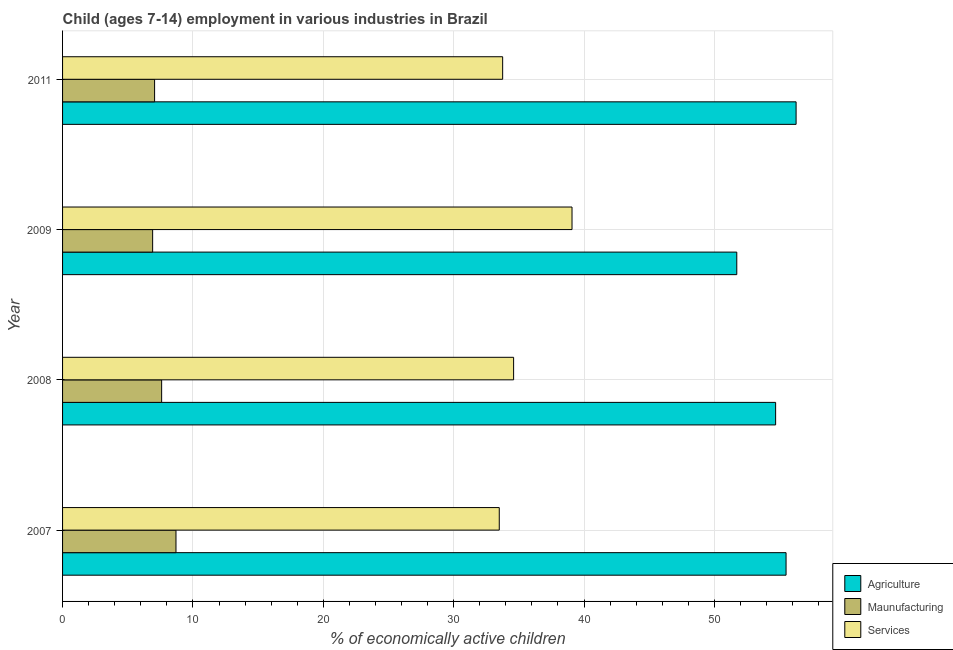How many different coloured bars are there?
Your response must be concise. 3. Are the number of bars per tick equal to the number of legend labels?
Offer a terse response. Yes. Are the number of bars on each tick of the Y-axis equal?
Make the answer very short. Yes. How many bars are there on the 1st tick from the top?
Make the answer very short. 3. How many bars are there on the 2nd tick from the bottom?
Offer a terse response. 3. What is the label of the 1st group of bars from the top?
Your answer should be compact. 2011. In how many cases, is the number of bars for a given year not equal to the number of legend labels?
Give a very brief answer. 0. What is the percentage of economically active children in services in 2011?
Offer a terse response. 33.76. Across all years, what is the maximum percentage of economically active children in agriculture?
Provide a short and direct response. 56.27. Across all years, what is the minimum percentage of economically active children in services?
Your answer should be very brief. 33.5. In which year was the percentage of economically active children in agriculture minimum?
Ensure brevity in your answer.  2009. What is the total percentage of economically active children in manufacturing in the graph?
Your answer should be compact. 30.27. What is the difference between the percentage of economically active children in services in 2007 and that in 2008?
Your answer should be compact. -1.1. What is the difference between the percentage of economically active children in agriculture in 2007 and the percentage of economically active children in manufacturing in 2009?
Your answer should be compact. 48.59. What is the average percentage of economically active children in agriculture per year?
Offer a very short reply. 54.55. In the year 2007, what is the difference between the percentage of economically active children in manufacturing and percentage of economically active children in services?
Provide a short and direct response. -24.8. What is the ratio of the percentage of economically active children in manufacturing in 2007 to that in 2011?
Ensure brevity in your answer.  1.23. What is the difference between the highest and the second highest percentage of economically active children in services?
Your response must be concise. 4.48. What is the difference between the highest and the lowest percentage of economically active children in agriculture?
Keep it short and to the point. 4.55. Is the sum of the percentage of economically active children in manufacturing in 2008 and 2011 greater than the maximum percentage of economically active children in agriculture across all years?
Your response must be concise. No. What does the 1st bar from the top in 2011 represents?
Keep it short and to the point. Services. What does the 3rd bar from the bottom in 2008 represents?
Provide a short and direct response. Services. Is it the case that in every year, the sum of the percentage of economically active children in agriculture and percentage of economically active children in manufacturing is greater than the percentage of economically active children in services?
Make the answer very short. Yes. How many bars are there?
Offer a very short reply. 12. Are all the bars in the graph horizontal?
Give a very brief answer. Yes. How many years are there in the graph?
Offer a very short reply. 4. Are the values on the major ticks of X-axis written in scientific E-notation?
Ensure brevity in your answer.  No. Does the graph contain any zero values?
Your response must be concise. No. How many legend labels are there?
Provide a short and direct response. 3. What is the title of the graph?
Offer a very short reply. Child (ages 7-14) employment in various industries in Brazil. Does "New Zealand" appear as one of the legend labels in the graph?
Give a very brief answer. No. What is the label or title of the X-axis?
Offer a very short reply. % of economically active children. What is the label or title of the Y-axis?
Offer a very short reply. Year. What is the % of economically active children of Agriculture in 2007?
Make the answer very short. 55.5. What is the % of economically active children in Maunufacturing in 2007?
Ensure brevity in your answer.  8.7. What is the % of economically active children of Services in 2007?
Make the answer very short. 33.5. What is the % of economically active children in Agriculture in 2008?
Ensure brevity in your answer.  54.7. What is the % of economically active children of Services in 2008?
Your response must be concise. 34.6. What is the % of economically active children of Agriculture in 2009?
Provide a succinct answer. 51.72. What is the % of economically active children in Maunufacturing in 2009?
Ensure brevity in your answer.  6.91. What is the % of economically active children in Services in 2009?
Give a very brief answer. 39.08. What is the % of economically active children of Agriculture in 2011?
Ensure brevity in your answer.  56.27. What is the % of economically active children in Maunufacturing in 2011?
Provide a succinct answer. 7.06. What is the % of economically active children of Services in 2011?
Give a very brief answer. 33.76. Across all years, what is the maximum % of economically active children of Agriculture?
Your answer should be very brief. 56.27. Across all years, what is the maximum % of economically active children of Services?
Make the answer very short. 39.08. Across all years, what is the minimum % of economically active children in Agriculture?
Make the answer very short. 51.72. Across all years, what is the minimum % of economically active children of Maunufacturing?
Your response must be concise. 6.91. Across all years, what is the minimum % of economically active children in Services?
Keep it short and to the point. 33.5. What is the total % of economically active children in Agriculture in the graph?
Your answer should be compact. 218.19. What is the total % of economically active children of Maunufacturing in the graph?
Make the answer very short. 30.27. What is the total % of economically active children in Services in the graph?
Give a very brief answer. 140.94. What is the difference between the % of economically active children of Agriculture in 2007 and that in 2008?
Provide a succinct answer. 0.8. What is the difference between the % of economically active children of Agriculture in 2007 and that in 2009?
Offer a terse response. 3.78. What is the difference between the % of economically active children of Maunufacturing in 2007 and that in 2009?
Keep it short and to the point. 1.79. What is the difference between the % of economically active children in Services in 2007 and that in 2009?
Offer a very short reply. -5.58. What is the difference between the % of economically active children of Agriculture in 2007 and that in 2011?
Your answer should be very brief. -0.77. What is the difference between the % of economically active children in Maunufacturing in 2007 and that in 2011?
Provide a succinct answer. 1.64. What is the difference between the % of economically active children in Services in 2007 and that in 2011?
Keep it short and to the point. -0.26. What is the difference between the % of economically active children in Agriculture in 2008 and that in 2009?
Give a very brief answer. 2.98. What is the difference between the % of economically active children in Maunufacturing in 2008 and that in 2009?
Your answer should be very brief. 0.69. What is the difference between the % of economically active children in Services in 2008 and that in 2009?
Your response must be concise. -4.48. What is the difference between the % of economically active children of Agriculture in 2008 and that in 2011?
Your answer should be very brief. -1.57. What is the difference between the % of economically active children in Maunufacturing in 2008 and that in 2011?
Your response must be concise. 0.54. What is the difference between the % of economically active children in Services in 2008 and that in 2011?
Your answer should be very brief. 0.84. What is the difference between the % of economically active children of Agriculture in 2009 and that in 2011?
Offer a terse response. -4.55. What is the difference between the % of economically active children in Maunufacturing in 2009 and that in 2011?
Your answer should be very brief. -0.15. What is the difference between the % of economically active children in Services in 2009 and that in 2011?
Provide a short and direct response. 5.32. What is the difference between the % of economically active children in Agriculture in 2007 and the % of economically active children in Maunufacturing in 2008?
Your answer should be compact. 47.9. What is the difference between the % of economically active children in Agriculture in 2007 and the % of economically active children in Services in 2008?
Provide a short and direct response. 20.9. What is the difference between the % of economically active children of Maunufacturing in 2007 and the % of economically active children of Services in 2008?
Make the answer very short. -25.9. What is the difference between the % of economically active children of Agriculture in 2007 and the % of economically active children of Maunufacturing in 2009?
Your answer should be compact. 48.59. What is the difference between the % of economically active children of Agriculture in 2007 and the % of economically active children of Services in 2009?
Offer a very short reply. 16.42. What is the difference between the % of economically active children of Maunufacturing in 2007 and the % of economically active children of Services in 2009?
Provide a short and direct response. -30.38. What is the difference between the % of economically active children in Agriculture in 2007 and the % of economically active children in Maunufacturing in 2011?
Provide a succinct answer. 48.44. What is the difference between the % of economically active children in Agriculture in 2007 and the % of economically active children in Services in 2011?
Your answer should be compact. 21.74. What is the difference between the % of economically active children of Maunufacturing in 2007 and the % of economically active children of Services in 2011?
Your answer should be compact. -25.06. What is the difference between the % of economically active children in Agriculture in 2008 and the % of economically active children in Maunufacturing in 2009?
Offer a terse response. 47.79. What is the difference between the % of economically active children in Agriculture in 2008 and the % of economically active children in Services in 2009?
Give a very brief answer. 15.62. What is the difference between the % of economically active children of Maunufacturing in 2008 and the % of economically active children of Services in 2009?
Your answer should be compact. -31.48. What is the difference between the % of economically active children in Agriculture in 2008 and the % of economically active children in Maunufacturing in 2011?
Offer a terse response. 47.64. What is the difference between the % of economically active children of Agriculture in 2008 and the % of economically active children of Services in 2011?
Make the answer very short. 20.94. What is the difference between the % of economically active children of Maunufacturing in 2008 and the % of economically active children of Services in 2011?
Keep it short and to the point. -26.16. What is the difference between the % of economically active children in Agriculture in 2009 and the % of economically active children in Maunufacturing in 2011?
Your response must be concise. 44.66. What is the difference between the % of economically active children in Agriculture in 2009 and the % of economically active children in Services in 2011?
Provide a short and direct response. 17.96. What is the difference between the % of economically active children of Maunufacturing in 2009 and the % of economically active children of Services in 2011?
Provide a succinct answer. -26.85. What is the average % of economically active children in Agriculture per year?
Your response must be concise. 54.55. What is the average % of economically active children in Maunufacturing per year?
Offer a very short reply. 7.57. What is the average % of economically active children in Services per year?
Provide a short and direct response. 35.23. In the year 2007, what is the difference between the % of economically active children in Agriculture and % of economically active children in Maunufacturing?
Ensure brevity in your answer.  46.8. In the year 2007, what is the difference between the % of economically active children in Agriculture and % of economically active children in Services?
Your answer should be very brief. 22. In the year 2007, what is the difference between the % of economically active children of Maunufacturing and % of economically active children of Services?
Give a very brief answer. -24.8. In the year 2008, what is the difference between the % of economically active children in Agriculture and % of economically active children in Maunufacturing?
Your answer should be very brief. 47.1. In the year 2008, what is the difference between the % of economically active children in Agriculture and % of economically active children in Services?
Provide a succinct answer. 20.1. In the year 2009, what is the difference between the % of economically active children of Agriculture and % of economically active children of Maunufacturing?
Ensure brevity in your answer.  44.81. In the year 2009, what is the difference between the % of economically active children of Agriculture and % of economically active children of Services?
Your answer should be very brief. 12.64. In the year 2009, what is the difference between the % of economically active children of Maunufacturing and % of economically active children of Services?
Ensure brevity in your answer.  -32.17. In the year 2011, what is the difference between the % of economically active children of Agriculture and % of economically active children of Maunufacturing?
Your response must be concise. 49.21. In the year 2011, what is the difference between the % of economically active children in Agriculture and % of economically active children in Services?
Make the answer very short. 22.51. In the year 2011, what is the difference between the % of economically active children in Maunufacturing and % of economically active children in Services?
Offer a very short reply. -26.7. What is the ratio of the % of economically active children in Agriculture in 2007 to that in 2008?
Offer a very short reply. 1.01. What is the ratio of the % of economically active children of Maunufacturing in 2007 to that in 2008?
Ensure brevity in your answer.  1.14. What is the ratio of the % of economically active children in Services in 2007 to that in 2008?
Your answer should be very brief. 0.97. What is the ratio of the % of economically active children in Agriculture in 2007 to that in 2009?
Offer a terse response. 1.07. What is the ratio of the % of economically active children of Maunufacturing in 2007 to that in 2009?
Make the answer very short. 1.26. What is the ratio of the % of economically active children in Services in 2007 to that in 2009?
Make the answer very short. 0.86. What is the ratio of the % of economically active children in Agriculture in 2007 to that in 2011?
Offer a very short reply. 0.99. What is the ratio of the % of economically active children of Maunufacturing in 2007 to that in 2011?
Provide a succinct answer. 1.23. What is the ratio of the % of economically active children of Services in 2007 to that in 2011?
Ensure brevity in your answer.  0.99. What is the ratio of the % of economically active children of Agriculture in 2008 to that in 2009?
Give a very brief answer. 1.06. What is the ratio of the % of economically active children in Maunufacturing in 2008 to that in 2009?
Your answer should be very brief. 1.1. What is the ratio of the % of economically active children of Services in 2008 to that in 2009?
Keep it short and to the point. 0.89. What is the ratio of the % of economically active children in Agriculture in 2008 to that in 2011?
Provide a short and direct response. 0.97. What is the ratio of the % of economically active children in Maunufacturing in 2008 to that in 2011?
Make the answer very short. 1.08. What is the ratio of the % of economically active children of Services in 2008 to that in 2011?
Offer a very short reply. 1.02. What is the ratio of the % of economically active children in Agriculture in 2009 to that in 2011?
Make the answer very short. 0.92. What is the ratio of the % of economically active children in Maunufacturing in 2009 to that in 2011?
Offer a very short reply. 0.98. What is the ratio of the % of economically active children in Services in 2009 to that in 2011?
Your response must be concise. 1.16. What is the difference between the highest and the second highest % of economically active children in Agriculture?
Keep it short and to the point. 0.77. What is the difference between the highest and the second highest % of economically active children in Maunufacturing?
Your answer should be compact. 1.1. What is the difference between the highest and the second highest % of economically active children in Services?
Keep it short and to the point. 4.48. What is the difference between the highest and the lowest % of economically active children of Agriculture?
Ensure brevity in your answer.  4.55. What is the difference between the highest and the lowest % of economically active children of Maunufacturing?
Offer a very short reply. 1.79. What is the difference between the highest and the lowest % of economically active children of Services?
Your answer should be very brief. 5.58. 